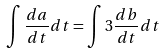<formula> <loc_0><loc_0><loc_500><loc_500>\int \frac { d a } { d t } d t = \int 3 \frac { d b } { d t } d t</formula> 